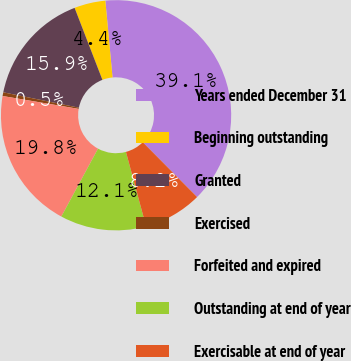Convert chart. <chart><loc_0><loc_0><loc_500><loc_500><pie_chart><fcel>Years ended December 31<fcel>Beginning outstanding<fcel>Granted<fcel>Exercised<fcel>Forfeited and expired<fcel>Outstanding at end of year<fcel>Exercisable at end of year<nl><fcel>39.06%<fcel>4.38%<fcel>15.94%<fcel>0.52%<fcel>19.79%<fcel>12.08%<fcel>8.23%<nl></chart> 